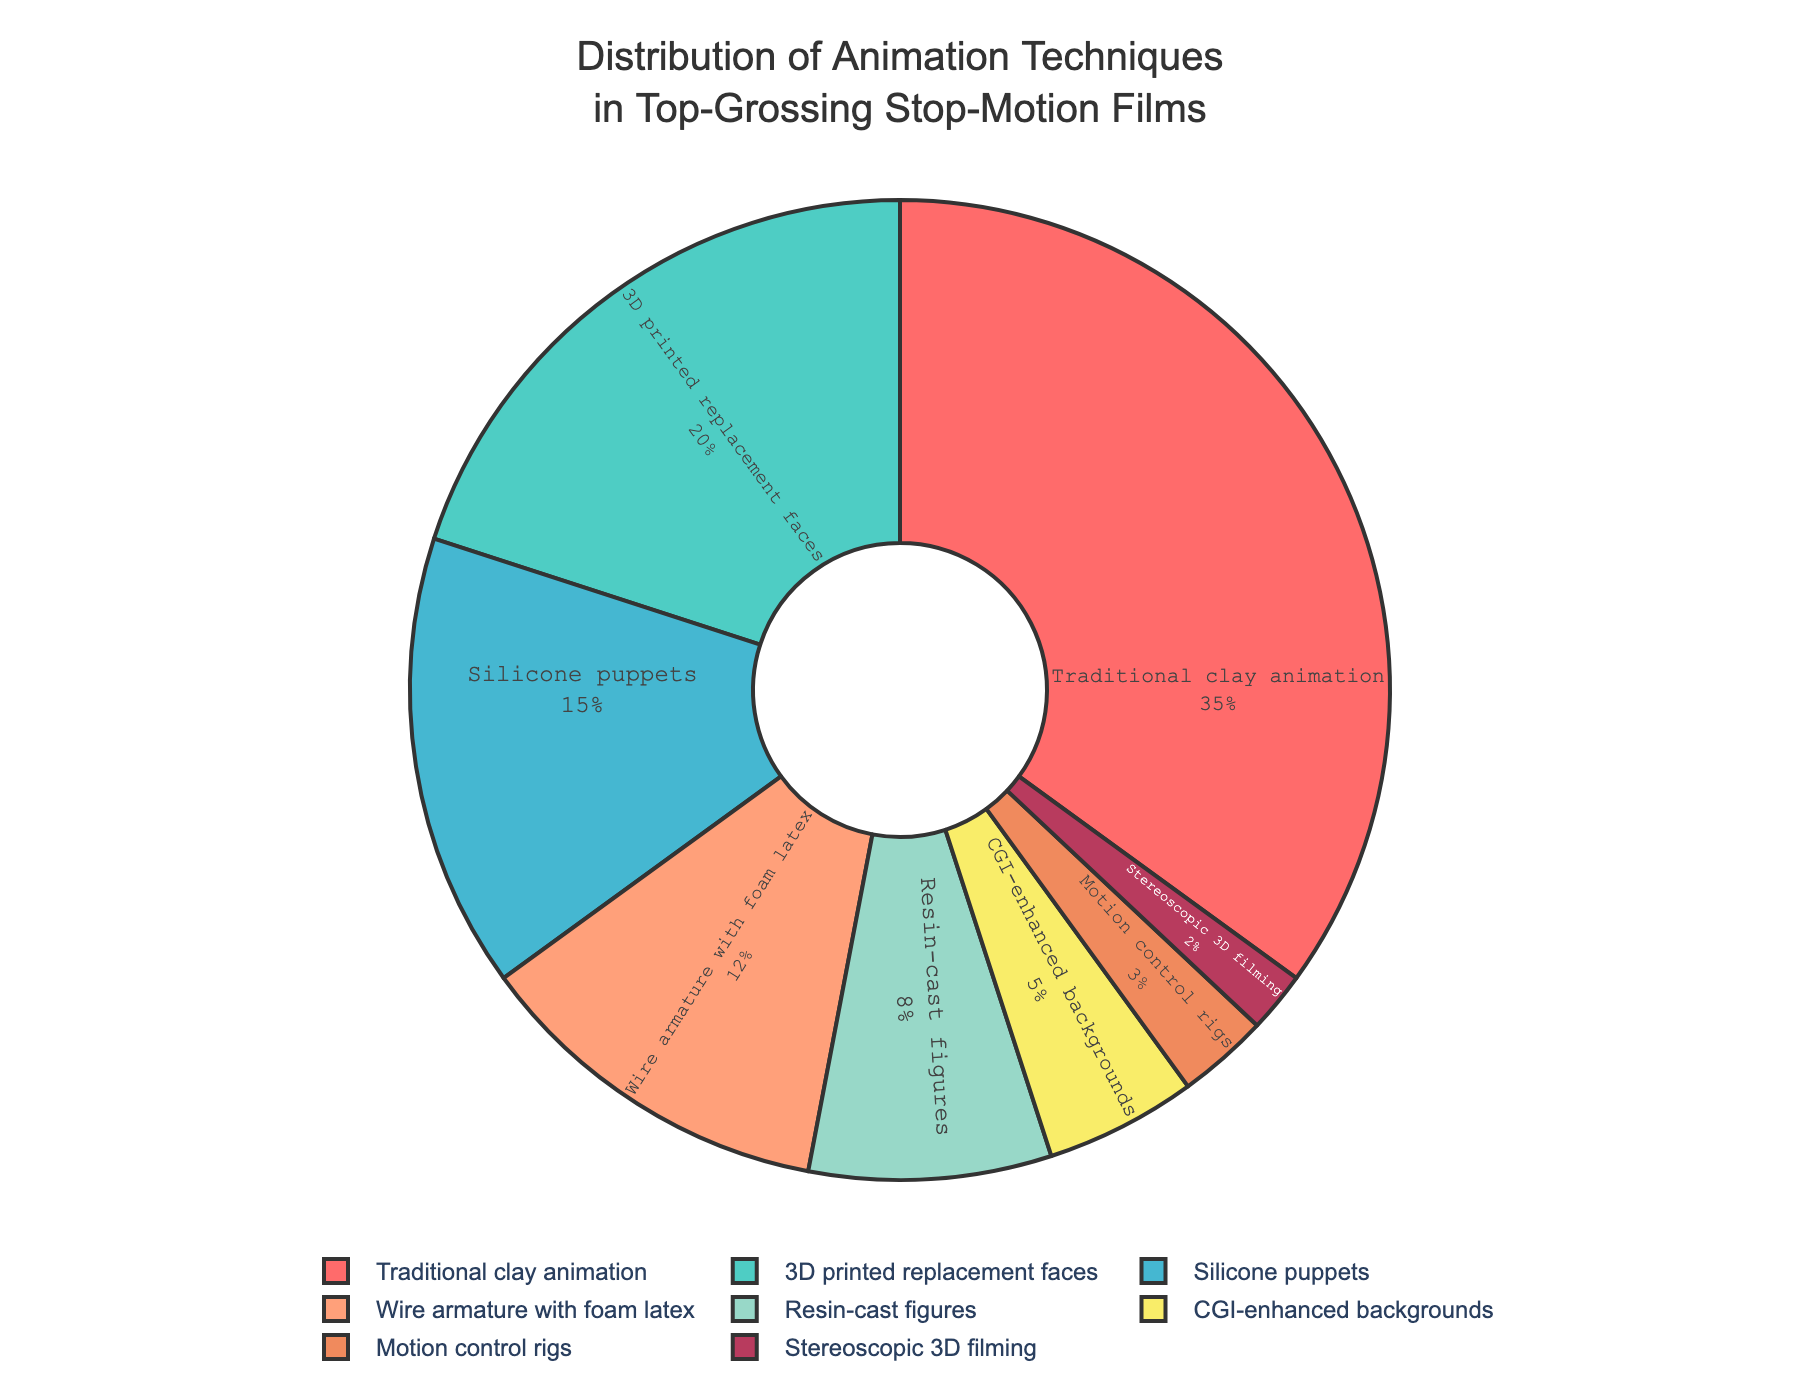What's the most used animation technique among top-grossing stop-motion films? The most used technique is represented by the largest slice of the pie chart. Traditional clay animation has the largest percentage.
Answer: Traditional clay animation What percentage of top-grossing stop-motion films use CGI-enhanced backgrounds? Locate the segment labeled "CGI-enhanced backgrounds" and read its percentage.
Answer: 5% How many techniques are used less than 10% of the time in these films? Identify all the slices with percentages less than 10%, count them: Resin-cast figures (8%), CGI-enhanced backgrounds (5%), Motion control rigs (3%), Stereoscopic 3D filming (2%).
Answer: 4 Compare the usage of 3D printed replacement faces and wire armature with foam latex techniques. Which one is more prevalent? Locate the two segments and compare their percentages: 3D printed replacement faces (20%) is higher than wire armature with foam latex (12%).
Answer: 3D printed replacement faces What's the combined percentage of techniques that use replacement faces and puppets? Sum the percentages of 3D printed replacement faces and silicone puppets: 20% + 15% = 35%.
Answer: 35% What color represents traditional clay animation on the pie chart? Find the segment labeled "Traditional clay animation" and note its color.
Answer: Red How much more prevalent is traditional clay animation compared to motion control rigs? Subtract the percentage of motion control rigs from that of traditional clay animation: 35% - 3% = 32%.
Answer: 32% What animation technique has the smallest percentage? Locate the technique with the smallest slice: Stereoscopic 3D filming (2%).
Answer: Stereoscopic 3D filming Which two techniques together account for 23% of the usage? Identify two techniques whose combined percentage equals 23%. Wire armature with foam latex (12%) + Resin-cast figures (8%) = 20% is closest match so far. None exactly match 23%, re-evaluate: Wire Armature with Silicone puppets (12% + 15%) = 27%. Motion control rigs (3%) + Resin-cast (8%) = 11%. 3D Printing (20%) + Motion control (3%) = 23%.
Answer: 3D printed replacement faces and Motion control rigs 